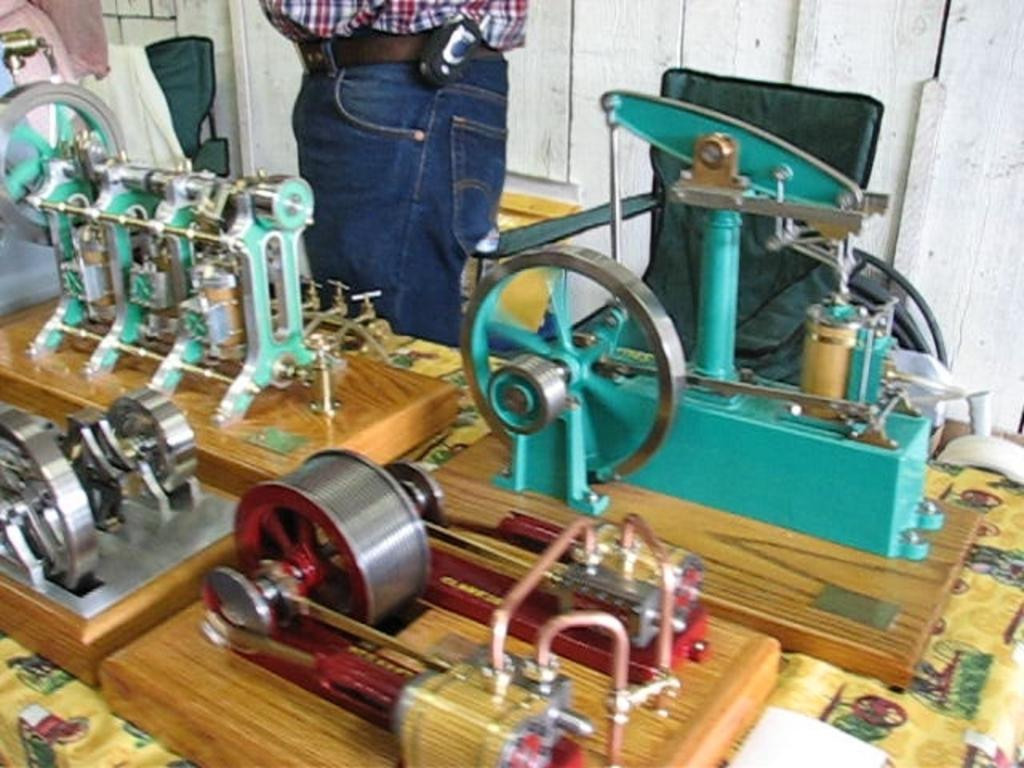What objects are on the table in the image? There are machines on the table in the image. Who is present in the image? There is a man standing behind the table in the image. Can you describe any furniture in the image? There is a chair in the image. What type of key is used to unlock the machines in the image? There is no key present in the image, and the machines do not require a key to operate. Can you see any popcorn being served from the machines in the image? There is no popcorn visible in the image, and the machines do not appear to be serving popcorn. 